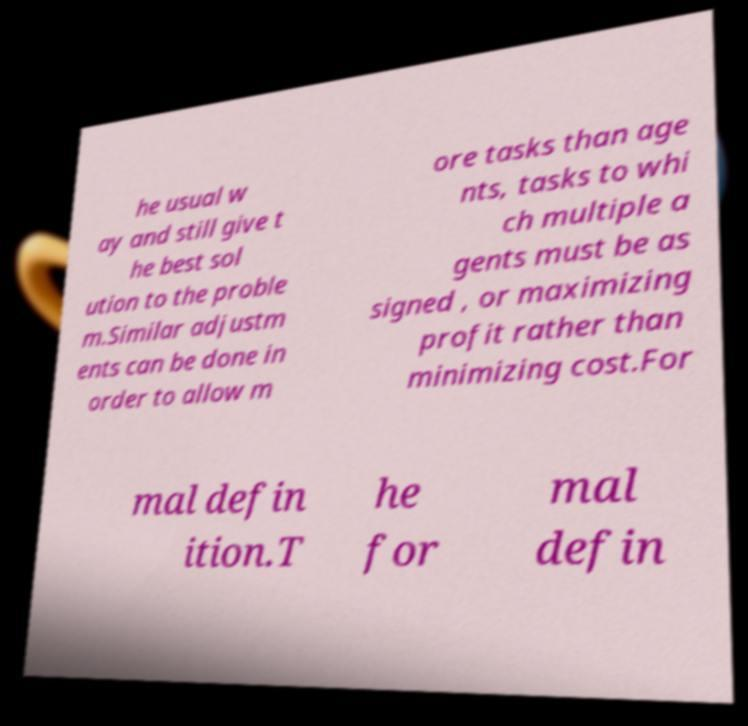I need the written content from this picture converted into text. Can you do that? he usual w ay and still give t he best sol ution to the proble m.Similar adjustm ents can be done in order to allow m ore tasks than age nts, tasks to whi ch multiple a gents must be as signed , or maximizing profit rather than minimizing cost.For mal defin ition.T he for mal defin 